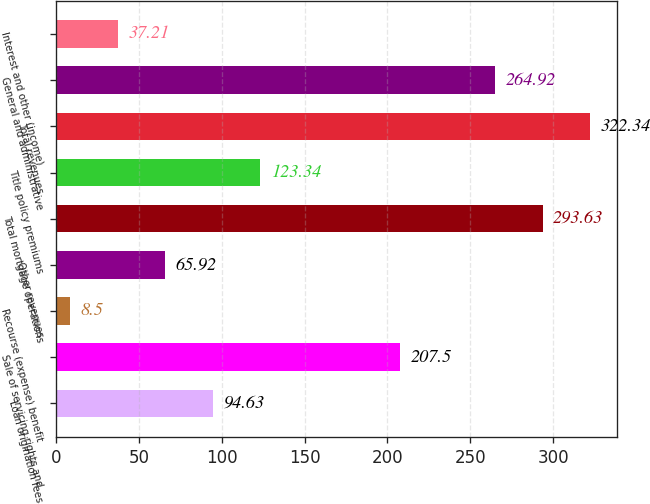Convert chart. <chart><loc_0><loc_0><loc_500><loc_500><bar_chart><fcel>Loan origination fees<fcel>Sale of servicing rights and<fcel>Recourse (expense) benefit<fcel>Other revenues<fcel>Total mortgage operations<fcel>Title policy premiums<fcel>Total revenues<fcel>General and administrative<fcel>Interest and other (income)<nl><fcel>94.63<fcel>207.5<fcel>8.5<fcel>65.92<fcel>293.63<fcel>123.34<fcel>322.34<fcel>264.92<fcel>37.21<nl></chart> 